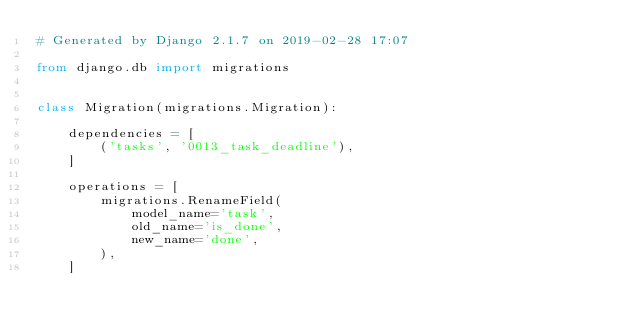<code> <loc_0><loc_0><loc_500><loc_500><_Python_># Generated by Django 2.1.7 on 2019-02-28 17:07

from django.db import migrations


class Migration(migrations.Migration):

    dependencies = [
        ('tasks', '0013_task_deadline'),
    ]

    operations = [
        migrations.RenameField(
            model_name='task',
            old_name='is_done',
            new_name='done',
        ),
    ]
</code> 